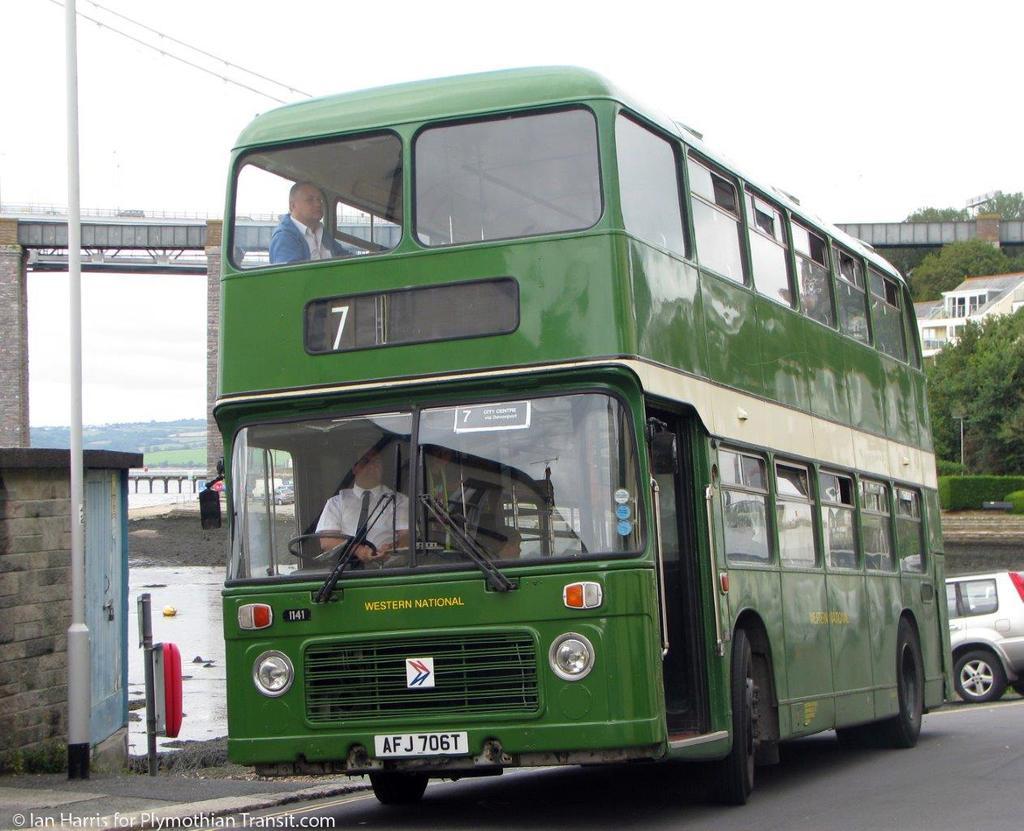Could you give a brief overview of what you see in this image? In the middle of this image, there is a bus on a road. On the bottom left, there is a watermark. In the background, there are buildings, trees, bridges, another vehicle, plants, water, cables and the sky. 